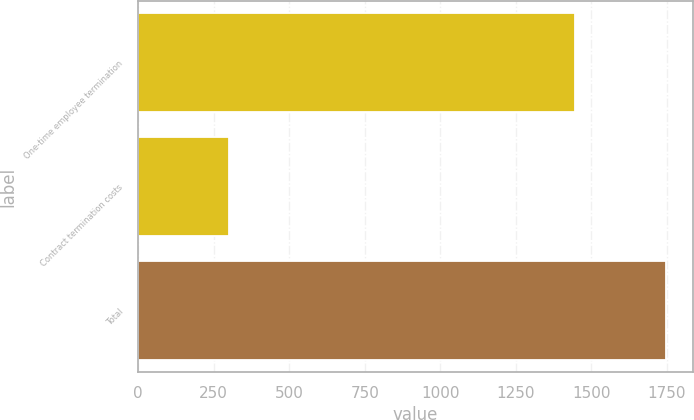<chart> <loc_0><loc_0><loc_500><loc_500><bar_chart><fcel>One-time employee termination<fcel>Contract termination costs<fcel>Total<nl><fcel>1447<fcel>301<fcel>1748<nl></chart> 